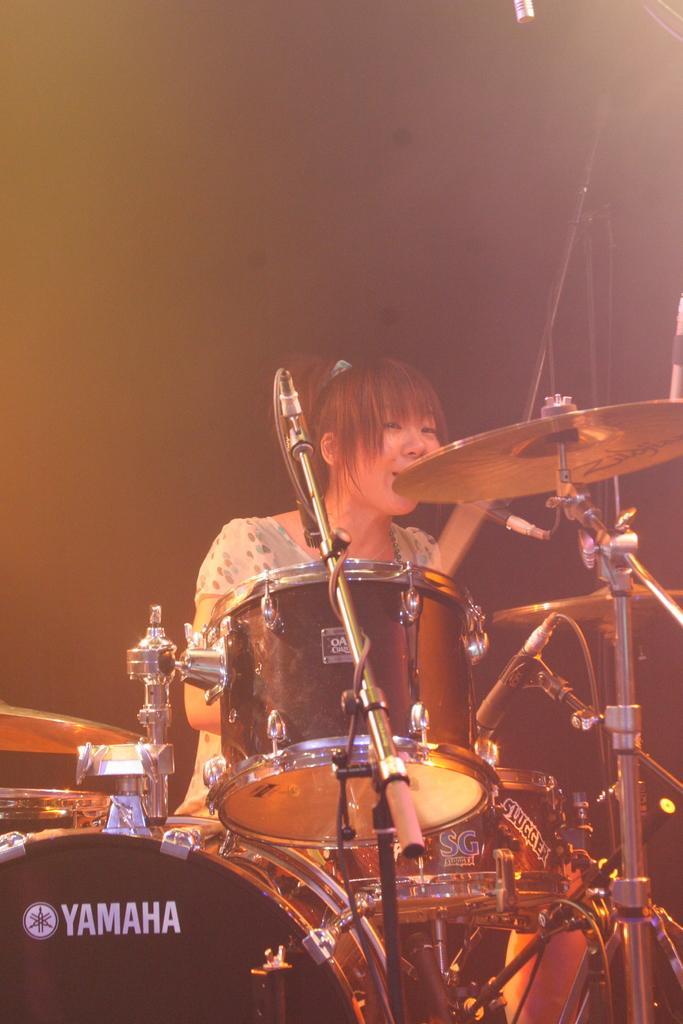How would you summarize this image in a sentence or two? In this picture I can see is holding sticks. Here I can see drums, microphones and other musical instruments. In the background I can see some objects. 